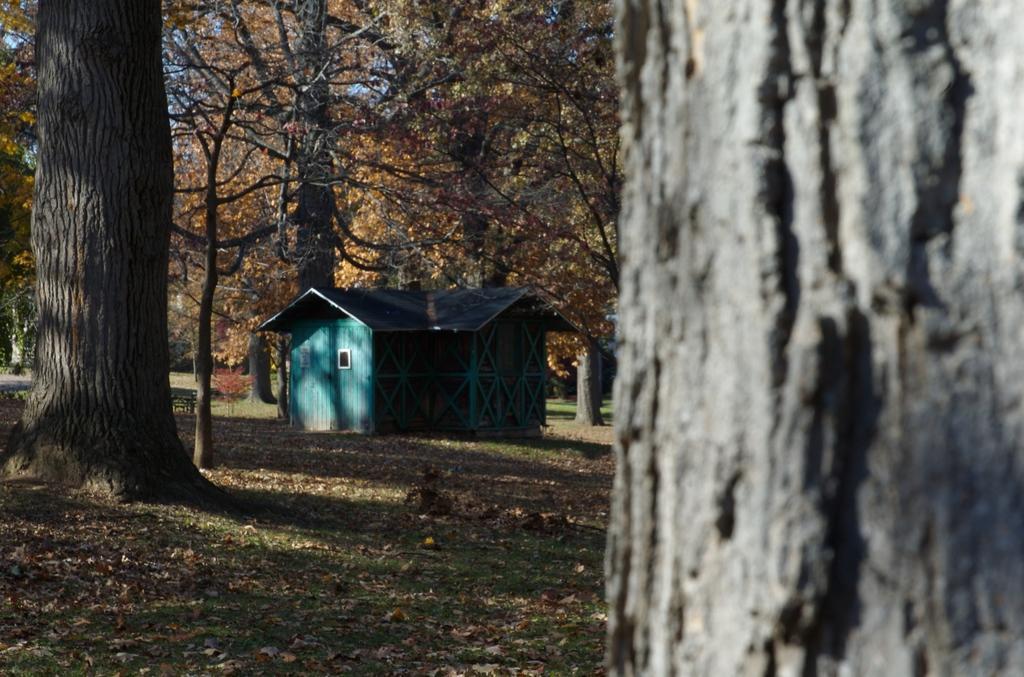Please provide a concise description of this image. In this image, we can see a house. We can see the ground covered with grass and dried leaves. There are a few trees. 